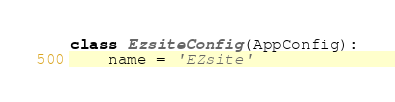Convert code to text. <code><loc_0><loc_0><loc_500><loc_500><_Python_>

class EzsiteConfig(AppConfig):
    name = 'EZsite'
</code> 